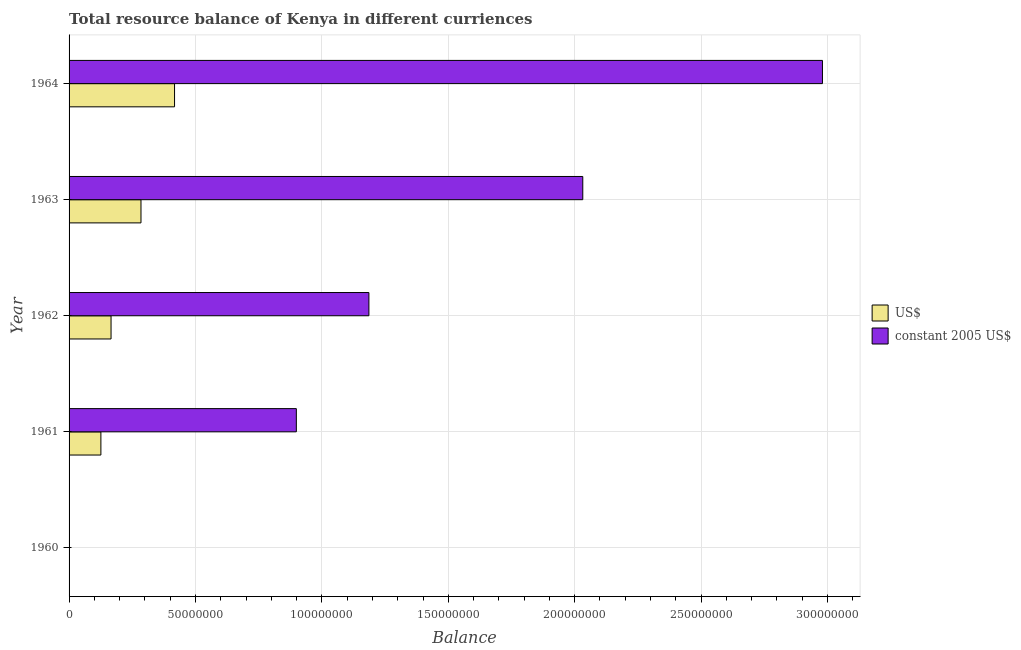How many bars are there on the 3rd tick from the top?
Your answer should be very brief. 2. What is the label of the 4th group of bars from the top?
Ensure brevity in your answer.  1961. In how many cases, is the number of bars for a given year not equal to the number of legend labels?
Ensure brevity in your answer.  1. What is the resource balance in us$ in 1964?
Offer a terse response. 4.17e+07. Across all years, what is the maximum resource balance in us$?
Make the answer very short. 4.17e+07. Across all years, what is the minimum resource balance in us$?
Offer a terse response. 0. In which year was the resource balance in us$ maximum?
Give a very brief answer. 1964. What is the total resource balance in constant us$ in the graph?
Offer a terse response. 7.10e+08. What is the difference between the resource balance in us$ in 1962 and that in 1963?
Offer a terse response. -1.18e+07. What is the difference between the resource balance in constant us$ in 1961 and the resource balance in us$ in 1962?
Make the answer very short. 7.33e+07. What is the average resource balance in us$ per year?
Offer a terse response. 1.99e+07. In the year 1962, what is the difference between the resource balance in us$ and resource balance in constant us$?
Your answer should be compact. -1.02e+08. In how many years, is the resource balance in us$ greater than 270000000 units?
Your answer should be very brief. 0. What is the ratio of the resource balance in us$ in 1962 to that in 1964?
Offer a very short reply. 0.4. Is the resource balance in constant us$ in 1961 less than that in 1964?
Ensure brevity in your answer.  Yes. What is the difference between the highest and the second highest resource balance in constant us$?
Your response must be concise. 9.48e+07. What is the difference between the highest and the lowest resource balance in us$?
Keep it short and to the point. 4.17e+07. Is the sum of the resource balance in us$ in 1963 and 1964 greater than the maximum resource balance in constant us$ across all years?
Make the answer very short. No. How many bars are there?
Provide a succinct answer. 8. Are all the bars in the graph horizontal?
Ensure brevity in your answer.  Yes. How many years are there in the graph?
Keep it short and to the point. 5. Does the graph contain grids?
Provide a succinct answer. Yes. How many legend labels are there?
Your answer should be compact. 2. How are the legend labels stacked?
Provide a short and direct response. Vertical. What is the title of the graph?
Your answer should be compact. Total resource balance of Kenya in different curriences. Does "Time to export" appear as one of the legend labels in the graph?
Provide a succinct answer. No. What is the label or title of the X-axis?
Offer a terse response. Balance. What is the label or title of the Y-axis?
Provide a succinct answer. Year. What is the Balance in US$ in 1960?
Offer a very short reply. 0. What is the Balance in constant 2005 US$ in 1960?
Your answer should be very brief. 0. What is the Balance of US$ in 1961?
Your response must be concise. 1.26e+07. What is the Balance of constant 2005 US$ in 1961?
Offer a terse response. 8.99e+07. What is the Balance in US$ in 1962?
Your answer should be compact. 1.66e+07. What is the Balance in constant 2005 US$ in 1962?
Give a very brief answer. 1.19e+08. What is the Balance in US$ in 1963?
Keep it short and to the point. 2.84e+07. What is the Balance of constant 2005 US$ in 1963?
Ensure brevity in your answer.  2.03e+08. What is the Balance of US$ in 1964?
Keep it short and to the point. 4.17e+07. What is the Balance of constant 2005 US$ in 1964?
Your answer should be compact. 2.98e+08. Across all years, what is the maximum Balance of US$?
Offer a very short reply. 4.17e+07. Across all years, what is the maximum Balance in constant 2005 US$?
Ensure brevity in your answer.  2.98e+08. Across all years, what is the minimum Balance in US$?
Keep it short and to the point. 0. What is the total Balance in US$ in the graph?
Offer a very short reply. 9.94e+07. What is the total Balance in constant 2005 US$ in the graph?
Offer a very short reply. 7.10e+08. What is the difference between the Balance of US$ in 1961 and that in 1962?
Offer a terse response. -4.02e+06. What is the difference between the Balance in constant 2005 US$ in 1961 and that in 1962?
Your answer should be compact. -2.87e+07. What is the difference between the Balance in US$ in 1961 and that in 1963?
Provide a succinct answer. -1.59e+07. What is the difference between the Balance of constant 2005 US$ in 1961 and that in 1963?
Keep it short and to the point. -1.13e+08. What is the difference between the Balance of US$ in 1961 and that in 1964?
Your response must be concise. -2.91e+07. What is the difference between the Balance of constant 2005 US$ in 1961 and that in 1964?
Your response must be concise. -2.08e+08. What is the difference between the Balance of US$ in 1962 and that in 1963?
Ensure brevity in your answer.  -1.18e+07. What is the difference between the Balance in constant 2005 US$ in 1962 and that in 1963?
Make the answer very short. -8.46e+07. What is the difference between the Balance of US$ in 1962 and that in 1964?
Make the answer very short. -2.51e+07. What is the difference between the Balance in constant 2005 US$ in 1962 and that in 1964?
Give a very brief answer. -1.79e+08. What is the difference between the Balance of US$ in 1963 and that in 1964?
Your answer should be compact. -1.33e+07. What is the difference between the Balance of constant 2005 US$ in 1963 and that in 1964?
Keep it short and to the point. -9.48e+07. What is the difference between the Balance in US$ in 1961 and the Balance in constant 2005 US$ in 1962?
Your response must be concise. -1.06e+08. What is the difference between the Balance of US$ in 1961 and the Balance of constant 2005 US$ in 1963?
Keep it short and to the point. -1.91e+08. What is the difference between the Balance of US$ in 1961 and the Balance of constant 2005 US$ in 1964?
Your answer should be compact. -2.85e+08. What is the difference between the Balance of US$ in 1962 and the Balance of constant 2005 US$ in 1963?
Offer a terse response. -1.87e+08. What is the difference between the Balance of US$ in 1962 and the Balance of constant 2005 US$ in 1964?
Offer a terse response. -2.81e+08. What is the difference between the Balance in US$ in 1963 and the Balance in constant 2005 US$ in 1964?
Your response must be concise. -2.70e+08. What is the average Balance in US$ per year?
Provide a succinct answer. 1.99e+07. What is the average Balance of constant 2005 US$ per year?
Give a very brief answer. 1.42e+08. In the year 1961, what is the difference between the Balance in US$ and Balance in constant 2005 US$?
Offer a very short reply. -7.73e+07. In the year 1962, what is the difference between the Balance in US$ and Balance in constant 2005 US$?
Offer a terse response. -1.02e+08. In the year 1963, what is the difference between the Balance of US$ and Balance of constant 2005 US$?
Your answer should be compact. -1.75e+08. In the year 1964, what is the difference between the Balance of US$ and Balance of constant 2005 US$?
Give a very brief answer. -2.56e+08. What is the ratio of the Balance of US$ in 1961 to that in 1962?
Provide a succinct answer. 0.76. What is the ratio of the Balance in constant 2005 US$ in 1961 to that in 1962?
Provide a succinct answer. 0.76. What is the ratio of the Balance of US$ in 1961 to that in 1963?
Your answer should be very brief. 0.44. What is the ratio of the Balance in constant 2005 US$ in 1961 to that in 1963?
Your answer should be compact. 0.44. What is the ratio of the Balance of US$ in 1961 to that in 1964?
Keep it short and to the point. 0.3. What is the ratio of the Balance of constant 2005 US$ in 1961 to that in 1964?
Offer a very short reply. 0.3. What is the ratio of the Balance of US$ in 1962 to that in 1963?
Your answer should be very brief. 0.58. What is the ratio of the Balance in constant 2005 US$ in 1962 to that in 1963?
Offer a very short reply. 0.58. What is the ratio of the Balance of US$ in 1962 to that in 1964?
Provide a succinct answer. 0.4. What is the ratio of the Balance in constant 2005 US$ in 1962 to that in 1964?
Ensure brevity in your answer.  0.4. What is the ratio of the Balance of US$ in 1963 to that in 1964?
Offer a very short reply. 0.68. What is the ratio of the Balance of constant 2005 US$ in 1963 to that in 1964?
Offer a very short reply. 0.68. What is the difference between the highest and the second highest Balance in US$?
Your answer should be compact. 1.33e+07. What is the difference between the highest and the second highest Balance in constant 2005 US$?
Provide a succinct answer. 9.48e+07. What is the difference between the highest and the lowest Balance of US$?
Offer a very short reply. 4.17e+07. What is the difference between the highest and the lowest Balance of constant 2005 US$?
Provide a succinct answer. 2.98e+08. 